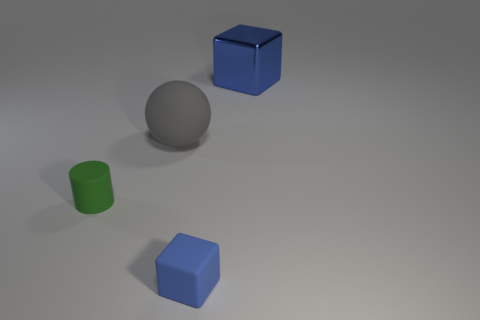The ball has what color? The ball in the image is a shade of silver, displaying a reflective surface that might be characteristic of materials such as steel or polished chrome. 